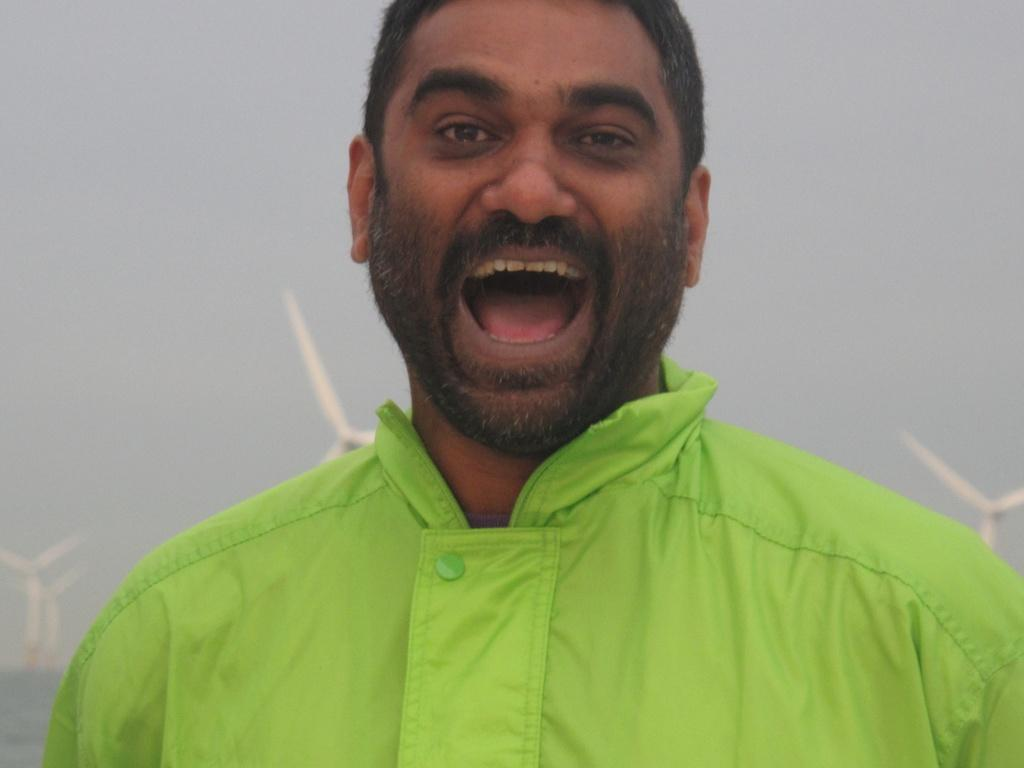Who is present in the image? There is a person in the image. What is the person wearing? The person is wearing a green dress. What can be seen in the background of the image? There is sky visible in the image. What type of structures are present in the image? There are windmills in the image. What type of trousers is the person wearing at the party in the image? The image does not show the person wearing trousers, nor does it depict a party. Additionally, the person's clothing has already been described as a green dress. 